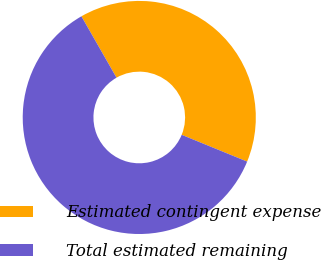<chart> <loc_0><loc_0><loc_500><loc_500><pie_chart><fcel>Estimated contingent expense<fcel>Total estimated remaining<nl><fcel>39.45%<fcel>60.55%<nl></chart> 